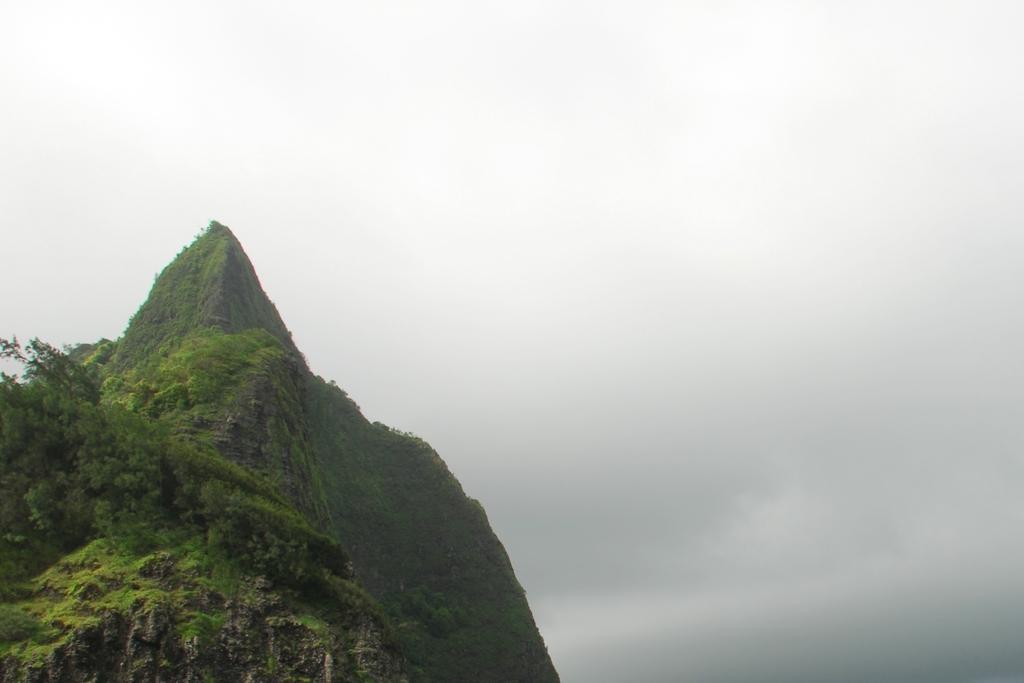Describe this image in one or two sentences. In this image I can see a hill. There are plants and in the background there is sky. 